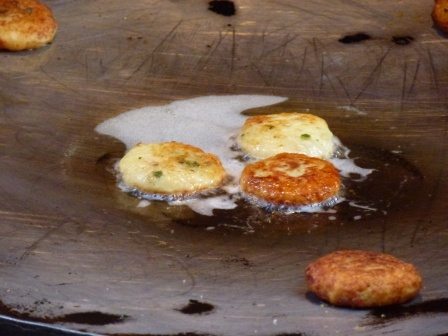How would you describe this image to someone who can’t see it? This image shows a kitchen scene focused on a black frying pan resting on a stovetop. In the pan, five small pancakes are cooking, all in different shades of golden brown, indicating various stages of readiness. The pancakes have green flecks, probably chives, adding a hint of color contrast. Oil glistens around the pancakes, hinting at a crispy texture developing. The overall feeling evoked is one of warmth, anticipation, and culinary delight. 